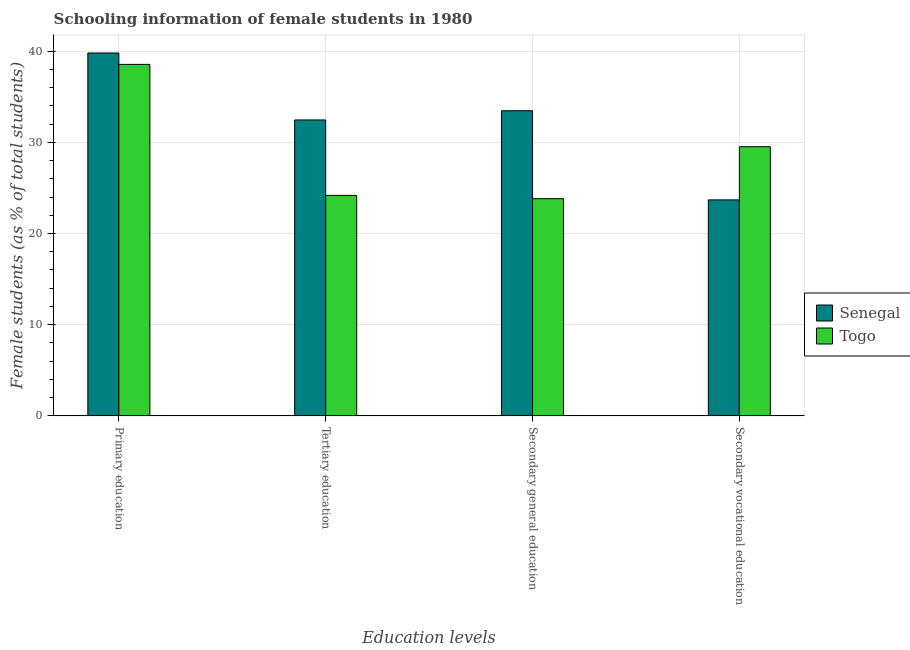How many groups of bars are there?
Give a very brief answer. 4. Are the number of bars on each tick of the X-axis equal?
Give a very brief answer. Yes. How many bars are there on the 2nd tick from the left?
Your answer should be very brief. 2. How many bars are there on the 4th tick from the right?
Give a very brief answer. 2. What is the label of the 3rd group of bars from the left?
Provide a short and direct response. Secondary general education. What is the percentage of female students in tertiary education in Senegal?
Ensure brevity in your answer.  32.45. Across all countries, what is the maximum percentage of female students in secondary vocational education?
Your answer should be compact. 29.52. Across all countries, what is the minimum percentage of female students in tertiary education?
Provide a succinct answer. 24.18. In which country was the percentage of female students in primary education maximum?
Keep it short and to the point. Senegal. In which country was the percentage of female students in tertiary education minimum?
Your response must be concise. Togo. What is the total percentage of female students in tertiary education in the graph?
Offer a terse response. 56.63. What is the difference between the percentage of female students in tertiary education in Senegal and that in Togo?
Your response must be concise. 8.27. What is the difference between the percentage of female students in tertiary education in Togo and the percentage of female students in primary education in Senegal?
Keep it short and to the point. -15.61. What is the average percentage of female students in secondary education per country?
Provide a short and direct response. 28.64. What is the difference between the percentage of female students in secondary vocational education and percentage of female students in tertiary education in Senegal?
Keep it short and to the point. -8.77. In how many countries, is the percentage of female students in primary education greater than 22 %?
Ensure brevity in your answer.  2. What is the ratio of the percentage of female students in primary education in Togo to that in Senegal?
Give a very brief answer. 0.97. Is the percentage of female students in tertiary education in Togo less than that in Senegal?
Ensure brevity in your answer.  Yes. Is the difference between the percentage of female students in tertiary education in Togo and Senegal greater than the difference between the percentage of female students in secondary education in Togo and Senegal?
Provide a succinct answer. Yes. What is the difference between the highest and the second highest percentage of female students in secondary education?
Give a very brief answer. 9.64. What is the difference between the highest and the lowest percentage of female students in tertiary education?
Provide a short and direct response. 8.27. Is it the case that in every country, the sum of the percentage of female students in primary education and percentage of female students in secondary education is greater than the sum of percentage of female students in tertiary education and percentage of female students in secondary vocational education?
Offer a very short reply. Yes. What does the 2nd bar from the left in Primary education represents?
Provide a succinct answer. Togo. What does the 1st bar from the right in Tertiary education represents?
Give a very brief answer. Togo. How many bars are there?
Keep it short and to the point. 8. Are all the bars in the graph horizontal?
Provide a succinct answer. No. What is the difference between two consecutive major ticks on the Y-axis?
Your answer should be compact. 10. Are the values on the major ticks of Y-axis written in scientific E-notation?
Make the answer very short. No. Does the graph contain grids?
Give a very brief answer. Yes. What is the title of the graph?
Ensure brevity in your answer.  Schooling information of female students in 1980. Does "Guinea-Bissau" appear as one of the legend labels in the graph?
Your response must be concise. No. What is the label or title of the X-axis?
Your answer should be very brief. Education levels. What is the label or title of the Y-axis?
Provide a succinct answer. Female students (as % of total students). What is the Female students (as % of total students) in Senegal in Primary education?
Provide a short and direct response. 39.79. What is the Female students (as % of total students) in Togo in Primary education?
Your answer should be compact. 38.55. What is the Female students (as % of total students) of Senegal in Tertiary education?
Offer a terse response. 32.45. What is the Female students (as % of total students) in Togo in Tertiary education?
Offer a terse response. 24.18. What is the Female students (as % of total students) in Senegal in Secondary general education?
Make the answer very short. 33.46. What is the Female students (as % of total students) of Togo in Secondary general education?
Offer a terse response. 23.82. What is the Female students (as % of total students) in Senegal in Secondary vocational education?
Your answer should be very brief. 23.69. What is the Female students (as % of total students) of Togo in Secondary vocational education?
Your response must be concise. 29.52. Across all Education levels, what is the maximum Female students (as % of total students) of Senegal?
Provide a short and direct response. 39.79. Across all Education levels, what is the maximum Female students (as % of total students) in Togo?
Give a very brief answer. 38.55. Across all Education levels, what is the minimum Female students (as % of total students) of Senegal?
Keep it short and to the point. 23.69. Across all Education levels, what is the minimum Female students (as % of total students) of Togo?
Provide a short and direct response. 23.82. What is the total Female students (as % of total students) in Senegal in the graph?
Make the answer very short. 129.4. What is the total Female students (as % of total students) of Togo in the graph?
Provide a succinct answer. 116.06. What is the difference between the Female students (as % of total students) of Senegal in Primary education and that in Tertiary education?
Your answer should be compact. 7.34. What is the difference between the Female students (as % of total students) of Togo in Primary education and that in Tertiary education?
Provide a succinct answer. 14.37. What is the difference between the Female students (as % of total students) in Senegal in Primary education and that in Secondary general education?
Keep it short and to the point. 6.33. What is the difference between the Female students (as % of total students) in Togo in Primary education and that in Secondary general education?
Offer a terse response. 14.73. What is the difference between the Female students (as % of total students) of Senegal in Primary education and that in Secondary vocational education?
Your response must be concise. 16.11. What is the difference between the Female students (as % of total students) in Togo in Primary education and that in Secondary vocational education?
Keep it short and to the point. 9.03. What is the difference between the Female students (as % of total students) in Senegal in Tertiary education and that in Secondary general education?
Your answer should be very brief. -1.01. What is the difference between the Female students (as % of total students) in Togo in Tertiary education and that in Secondary general education?
Offer a terse response. 0.36. What is the difference between the Female students (as % of total students) in Senegal in Tertiary education and that in Secondary vocational education?
Offer a very short reply. 8.77. What is the difference between the Female students (as % of total students) of Togo in Tertiary education and that in Secondary vocational education?
Keep it short and to the point. -5.34. What is the difference between the Female students (as % of total students) of Senegal in Secondary general education and that in Secondary vocational education?
Provide a succinct answer. 9.78. What is the difference between the Female students (as % of total students) of Togo in Secondary general education and that in Secondary vocational education?
Provide a short and direct response. -5.7. What is the difference between the Female students (as % of total students) in Senegal in Primary education and the Female students (as % of total students) in Togo in Tertiary education?
Your answer should be very brief. 15.61. What is the difference between the Female students (as % of total students) of Senegal in Primary education and the Female students (as % of total students) of Togo in Secondary general education?
Give a very brief answer. 15.98. What is the difference between the Female students (as % of total students) of Senegal in Primary education and the Female students (as % of total students) of Togo in Secondary vocational education?
Your answer should be very brief. 10.27. What is the difference between the Female students (as % of total students) in Senegal in Tertiary education and the Female students (as % of total students) in Togo in Secondary general education?
Your answer should be very brief. 8.64. What is the difference between the Female students (as % of total students) of Senegal in Tertiary education and the Female students (as % of total students) of Togo in Secondary vocational education?
Your response must be concise. 2.93. What is the difference between the Female students (as % of total students) of Senegal in Secondary general education and the Female students (as % of total students) of Togo in Secondary vocational education?
Provide a short and direct response. 3.94. What is the average Female students (as % of total students) in Senegal per Education levels?
Your response must be concise. 32.35. What is the average Female students (as % of total students) in Togo per Education levels?
Give a very brief answer. 29.02. What is the difference between the Female students (as % of total students) of Senegal and Female students (as % of total students) of Togo in Primary education?
Offer a terse response. 1.25. What is the difference between the Female students (as % of total students) of Senegal and Female students (as % of total students) of Togo in Tertiary education?
Ensure brevity in your answer.  8.27. What is the difference between the Female students (as % of total students) in Senegal and Female students (as % of total students) in Togo in Secondary general education?
Your answer should be very brief. 9.64. What is the difference between the Female students (as % of total students) of Senegal and Female students (as % of total students) of Togo in Secondary vocational education?
Ensure brevity in your answer.  -5.83. What is the ratio of the Female students (as % of total students) of Senegal in Primary education to that in Tertiary education?
Provide a short and direct response. 1.23. What is the ratio of the Female students (as % of total students) in Togo in Primary education to that in Tertiary education?
Provide a short and direct response. 1.59. What is the ratio of the Female students (as % of total students) in Senegal in Primary education to that in Secondary general education?
Make the answer very short. 1.19. What is the ratio of the Female students (as % of total students) in Togo in Primary education to that in Secondary general education?
Make the answer very short. 1.62. What is the ratio of the Female students (as % of total students) in Senegal in Primary education to that in Secondary vocational education?
Offer a very short reply. 1.68. What is the ratio of the Female students (as % of total students) of Togo in Primary education to that in Secondary vocational education?
Ensure brevity in your answer.  1.31. What is the ratio of the Female students (as % of total students) in Senegal in Tertiary education to that in Secondary general education?
Your response must be concise. 0.97. What is the ratio of the Female students (as % of total students) in Togo in Tertiary education to that in Secondary general education?
Give a very brief answer. 1.02. What is the ratio of the Female students (as % of total students) in Senegal in Tertiary education to that in Secondary vocational education?
Make the answer very short. 1.37. What is the ratio of the Female students (as % of total students) of Togo in Tertiary education to that in Secondary vocational education?
Give a very brief answer. 0.82. What is the ratio of the Female students (as % of total students) in Senegal in Secondary general education to that in Secondary vocational education?
Offer a very short reply. 1.41. What is the ratio of the Female students (as % of total students) in Togo in Secondary general education to that in Secondary vocational education?
Make the answer very short. 0.81. What is the difference between the highest and the second highest Female students (as % of total students) in Senegal?
Provide a short and direct response. 6.33. What is the difference between the highest and the second highest Female students (as % of total students) of Togo?
Your answer should be very brief. 9.03. What is the difference between the highest and the lowest Female students (as % of total students) of Senegal?
Offer a terse response. 16.11. What is the difference between the highest and the lowest Female students (as % of total students) in Togo?
Make the answer very short. 14.73. 